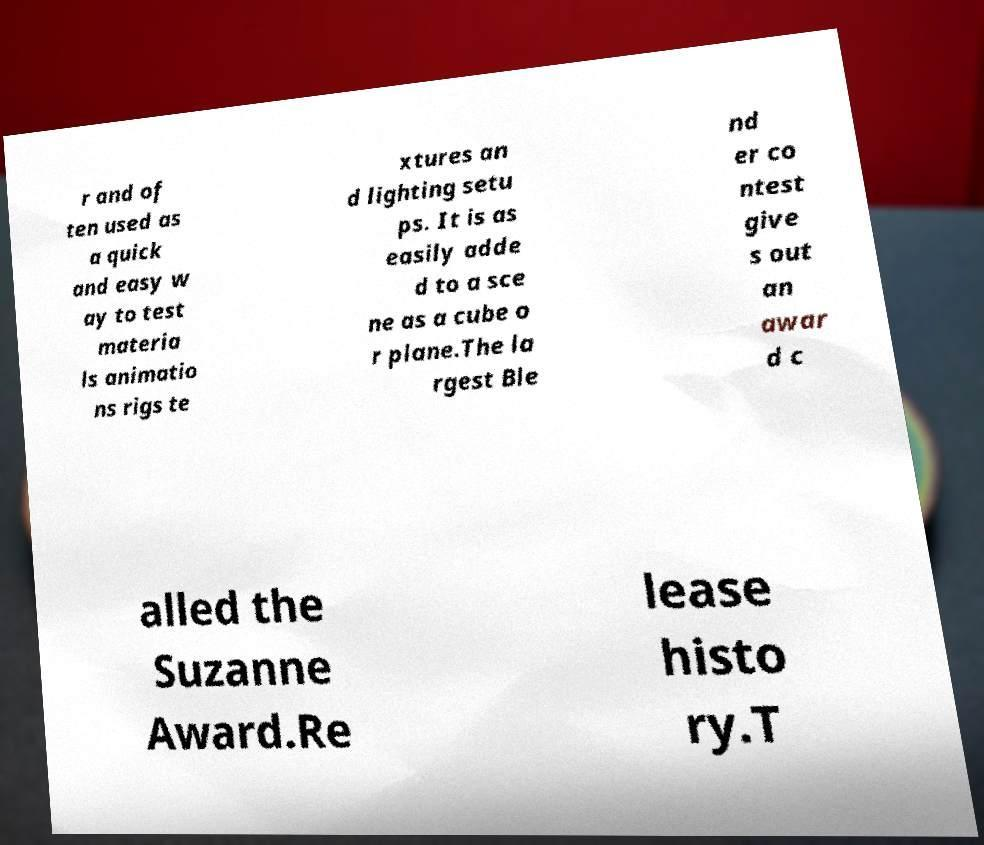Could you assist in decoding the text presented in this image and type it out clearly? r and of ten used as a quick and easy w ay to test materia ls animatio ns rigs te xtures an d lighting setu ps. It is as easily adde d to a sce ne as a cube o r plane.The la rgest Ble nd er co ntest give s out an awar d c alled the Suzanne Award.Re lease histo ry.T 